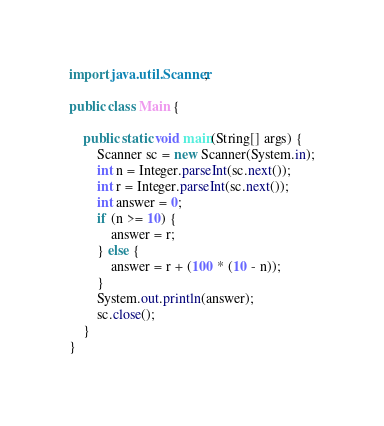<code> <loc_0><loc_0><loc_500><loc_500><_Java_>import java.util.Scanner;

public class Main {

    public static void main(String[] args) {
        Scanner sc = new Scanner(System.in);
        int n = Integer.parseInt(sc.next());
        int r = Integer.parseInt(sc.next());
        int answer = 0;
        if (n >= 10) {
            answer = r;
        } else {
            answer = r + (100 * (10 - n));
        }
        System.out.println(answer);
        sc.close();
    }
}
</code> 